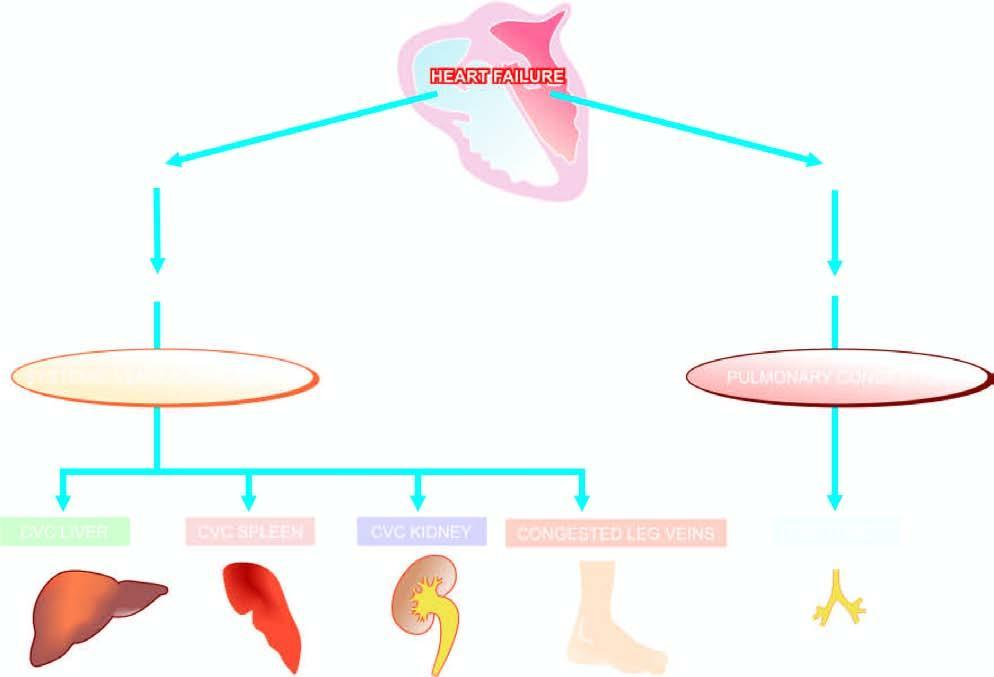what is involved in chronic venous congestion of different organs?
Answer the question using a single word or phrase. Schematic representation of mechanisms 